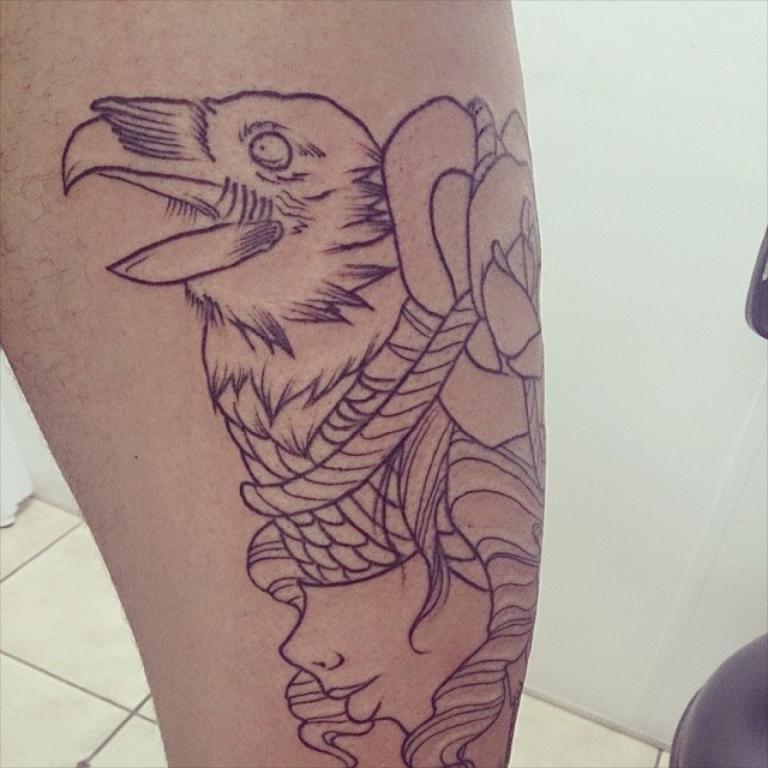How would you summarize this image in a sentence or two? In this picture I can see there is a tattoo on the body of a person, there is a wall in the backdrop and a chair at the right side. 